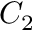Convert formula to latex. <formula><loc_0><loc_0><loc_500><loc_500>C _ { 2 }</formula> 